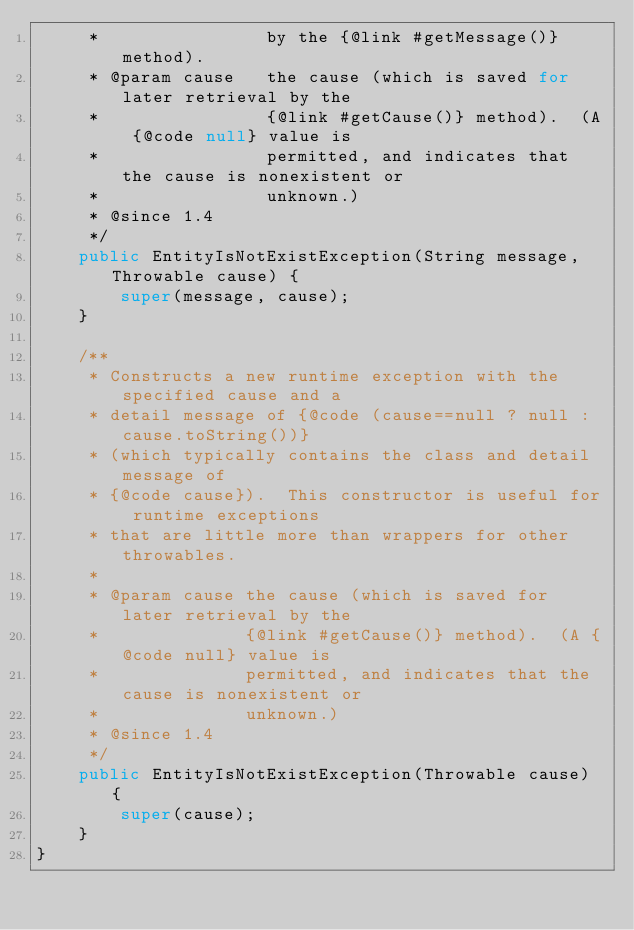Convert code to text. <code><loc_0><loc_0><loc_500><loc_500><_Java_>     *                by the {@link #getMessage()} method).
     * @param cause   the cause (which is saved for later retrieval by the
     *                {@link #getCause()} method).  (A {@code null} value is
     *                permitted, and indicates that the cause is nonexistent or
     *                unknown.)
     * @since 1.4
     */
    public EntityIsNotExistException(String message, Throwable cause) {
        super(message, cause);
    }

    /**
     * Constructs a new runtime exception with the specified cause and a
     * detail message of {@code (cause==null ? null : cause.toString())}
     * (which typically contains the class and detail message of
     * {@code cause}).  This constructor is useful for runtime exceptions
     * that are little more than wrappers for other throwables.
     *
     * @param cause the cause (which is saved for later retrieval by the
     *              {@link #getCause()} method).  (A {@code null} value is
     *              permitted, and indicates that the cause is nonexistent or
     *              unknown.)
     * @since 1.4
     */
    public EntityIsNotExistException(Throwable cause) {
        super(cause);
    }
}
</code> 